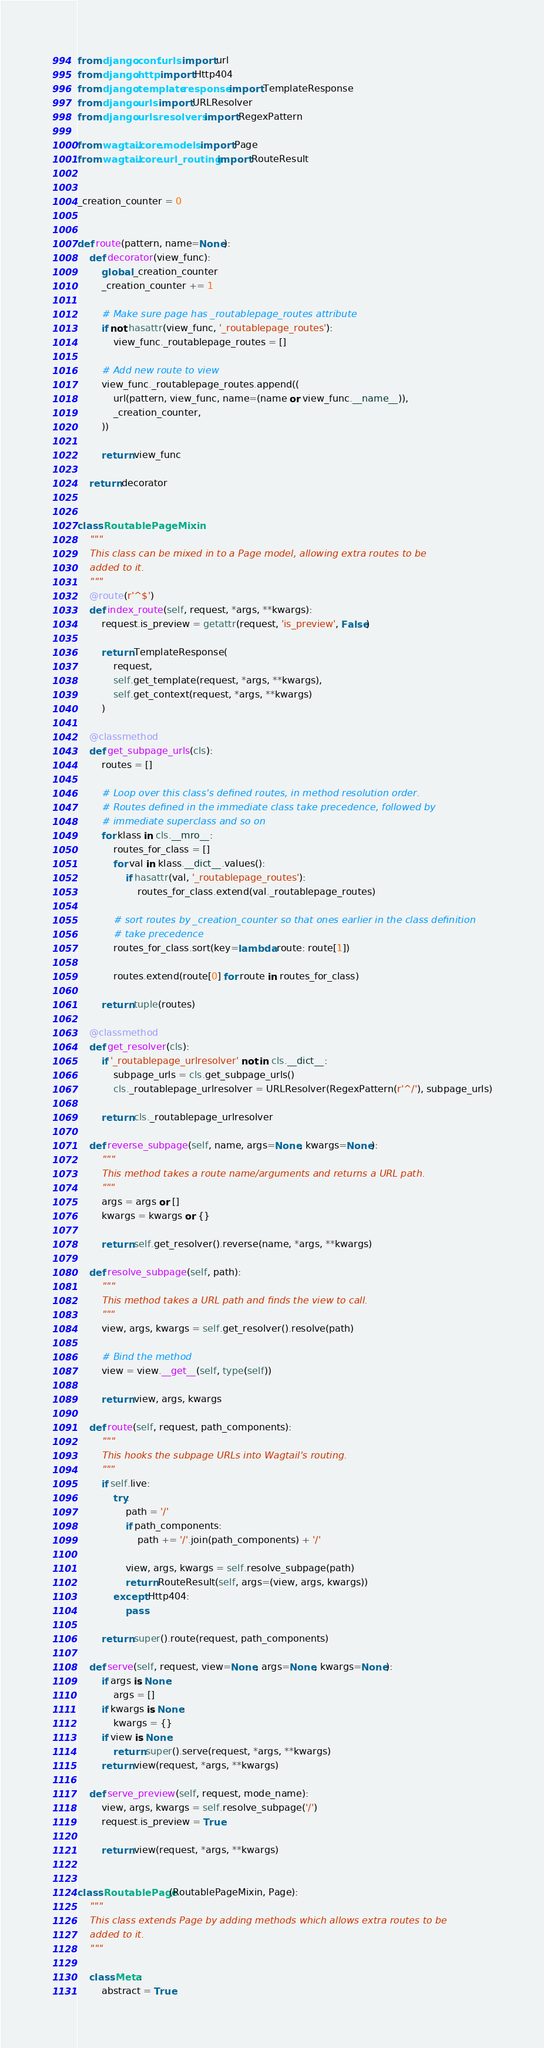<code> <loc_0><loc_0><loc_500><loc_500><_Python_>from django.conf.urls import url
from django.http import Http404
from django.template.response import TemplateResponse
from django.urls import URLResolver
from django.urls.resolvers import RegexPattern

from wagtail.core.models import Page
from wagtail.core.url_routing import RouteResult


_creation_counter = 0


def route(pattern, name=None):
    def decorator(view_func):
        global _creation_counter
        _creation_counter += 1

        # Make sure page has _routablepage_routes attribute
        if not hasattr(view_func, '_routablepage_routes'):
            view_func._routablepage_routes = []

        # Add new route to view
        view_func._routablepage_routes.append((
            url(pattern, view_func, name=(name or view_func.__name__)),
            _creation_counter,
        ))

        return view_func

    return decorator


class RoutablePageMixin:
    """
    This class can be mixed in to a Page model, allowing extra routes to be
    added to it.
    """
    @route(r'^$')
    def index_route(self, request, *args, **kwargs):
        request.is_preview = getattr(request, 'is_preview', False)

        return TemplateResponse(
            request,
            self.get_template(request, *args, **kwargs),
            self.get_context(request, *args, **kwargs)
        )

    @classmethod
    def get_subpage_urls(cls):
        routes = []

        # Loop over this class's defined routes, in method resolution order.
        # Routes defined in the immediate class take precedence, followed by
        # immediate superclass and so on
        for klass in cls.__mro__:
            routes_for_class = []
            for val in klass.__dict__.values():
                if hasattr(val, '_routablepage_routes'):
                    routes_for_class.extend(val._routablepage_routes)

            # sort routes by _creation_counter so that ones earlier in the class definition
            # take precedence
            routes_for_class.sort(key=lambda route: route[1])

            routes.extend(route[0] for route in routes_for_class)

        return tuple(routes)

    @classmethod
    def get_resolver(cls):
        if '_routablepage_urlresolver' not in cls.__dict__:
            subpage_urls = cls.get_subpage_urls()
            cls._routablepage_urlresolver = URLResolver(RegexPattern(r'^/'), subpage_urls)

        return cls._routablepage_urlresolver

    def reverse_subpage(self, name, args=None, kwargs=None):
        """
        This method takes a route name/arguments and returns a URL path.
        """
        args = args or []
        kwargs = kwargs or {}

        return self.get_resolver().reverse(name, *args, **kwargs)

    def resolve_subpage(self, path):
        """
        This method takes a URL path and finds the view to call.
        """
        view, args, kwargs = self.get_resolver().resolve(path)

        # Bind the method
        view = view.__get__(self, type(self))

        return view, args, kwargs

    def route(self, request, path_components):
        """
        This hooks the subpage URLs into Wagtail's routing.
        """
        if self.live:
            try:
                path = '/'
                if path_components:
                    path += '/'.join(path_components) + '/'

                view, args, kwargs = self.resolve_subpage(path)
                return RouteResult(self, args=(view, args, kwargs))
            except Http404:
                pass

        return super().route(request, path_components)

    def serve(self, request, view=None, args=None, kwargs=None):
        if args is None:
            args = []
        if kwargs is None:
            kwargs = {}
        if view is None:
            return super().serve(request, *args, **kwargs)
        return view(request, *args, **kwargs)

    def serve_preview(self, request, mode_name):
        view, args, kwargs = self.resolve_subpage('/')
        request.is_preview = True

        return view(request, *args, **kwargs)


class RoutablePage(RoutablePageMixin, Page):
    """
    This class extends Page by adding methods which allows extra routes to be
    added to it.
    """

    class Meta:
        abstract = True
</code> 